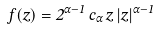<formula> <loc_0><loc_0><loc_500><loc_500>f ( z ) = 2 ^ { \alpha - 1 } \, c _ { \alpha } \, z \, | z | ^ { \alpha - 1 }</formula> 